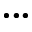<formula> <loc_0><loc_0><loc_500><loc_500>\bullet \bullet \bullet</formula> 